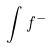<formula> <loc_0><loc_0><loc_500><loc_500>\int f ^ { - }</formula> 